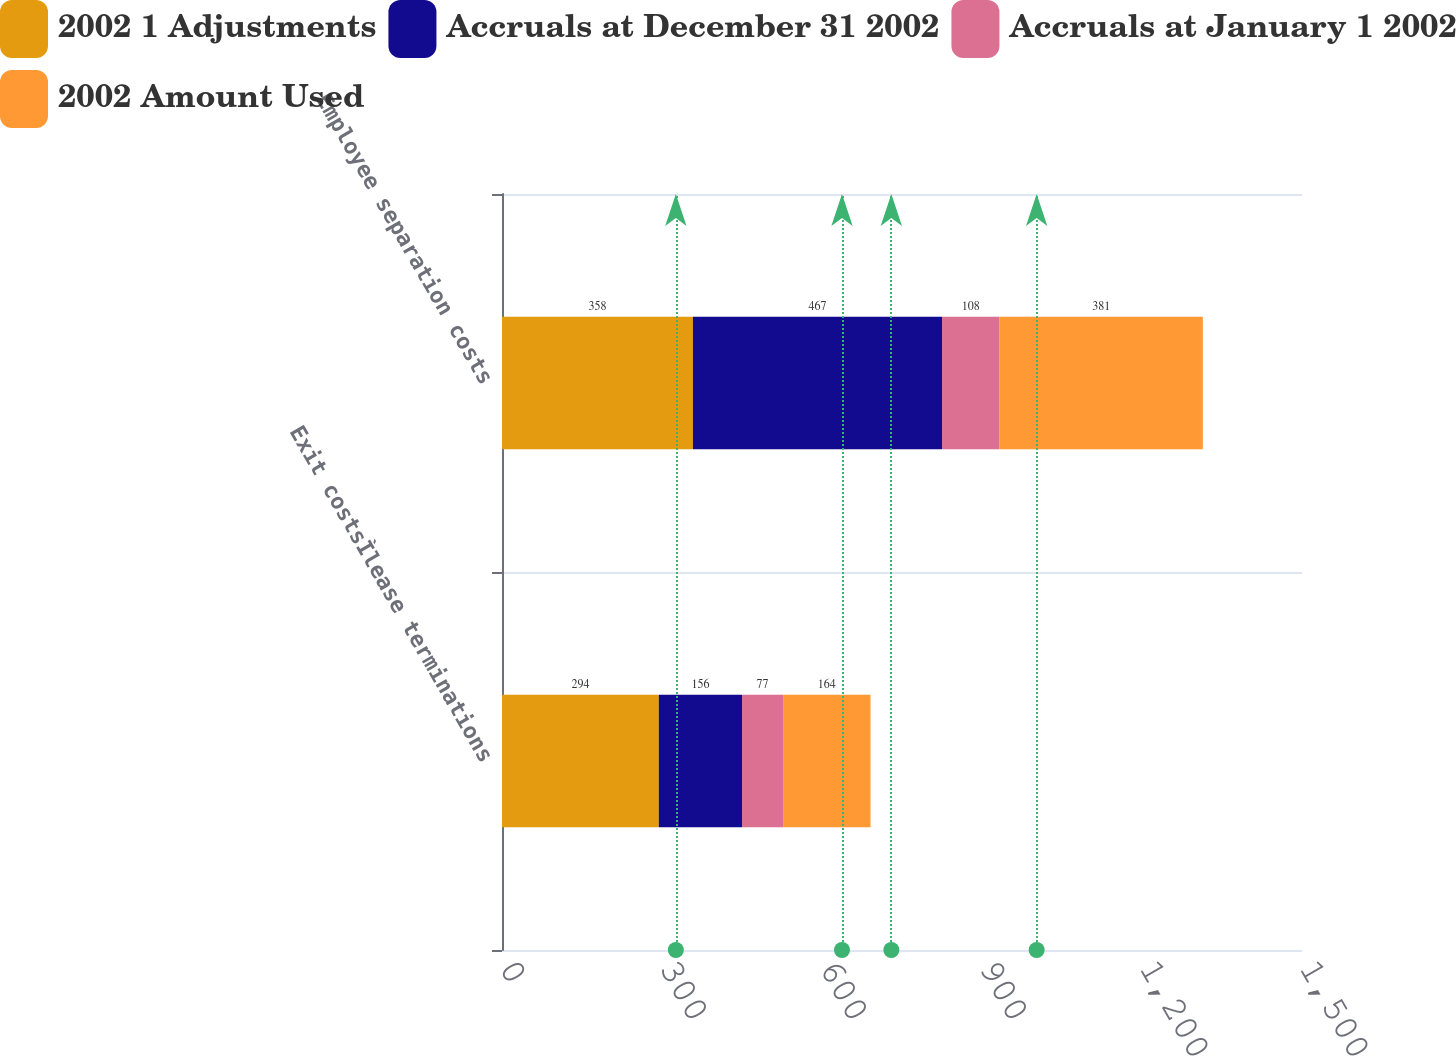Convert chart to OTSL. <chart><loc_0><loc_0><loc_500><loc_500><stacked_bar_chart><ecel><fcel>Exit costsÌlease terminations<fcel>Employee separation costs<nl><fcel>2002 1 Adjustments<fcel>294<fcel>358<nl><fcel>Accruals at December 31 2002<fcel>156<fcel>467<nl><fcel>Accruals at January 1 2002<fcel>77<fcel>108<nl><fcel>2002 Amount Used<fcel>164<fcel>381<nl></chart> 